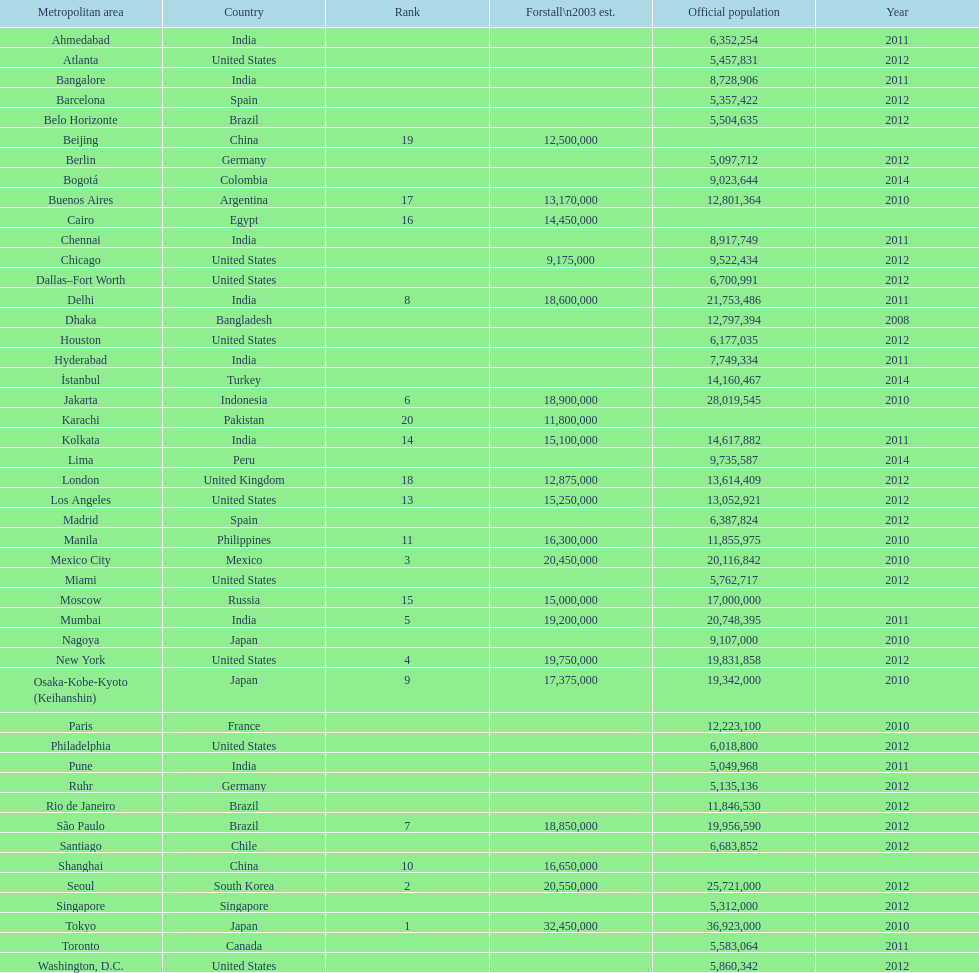Which areas had a population of more than 10,000,000 but less than 20,000,000? Buenos Aires, Dhaka, İstanbul, Kolkata, London, Los Angeles, Manila, Moscow, New York, Osaka-Kobe-Kyoto (Keihanshin), Paris, Rio de Janeiro, São Paulo. 